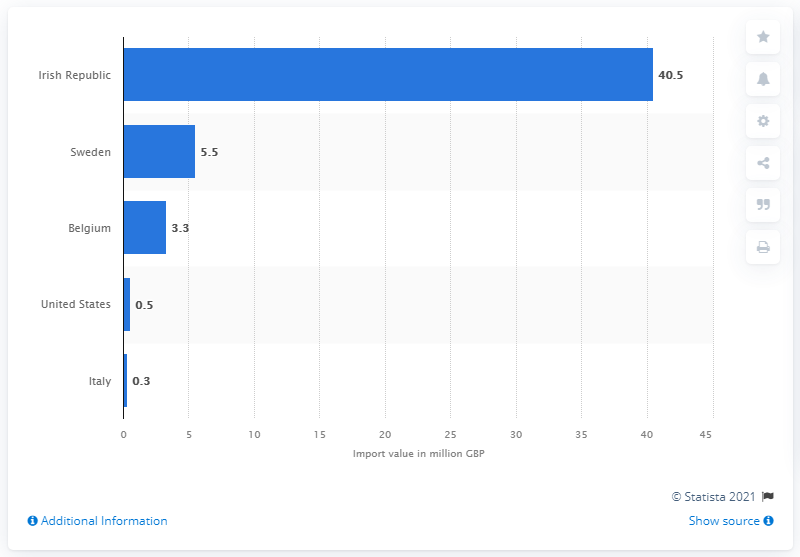Identify some key points in this picture. In 2020, the value of Ireland's cider imports to the United Kingdom was approximately 40.5 million British pounds. 